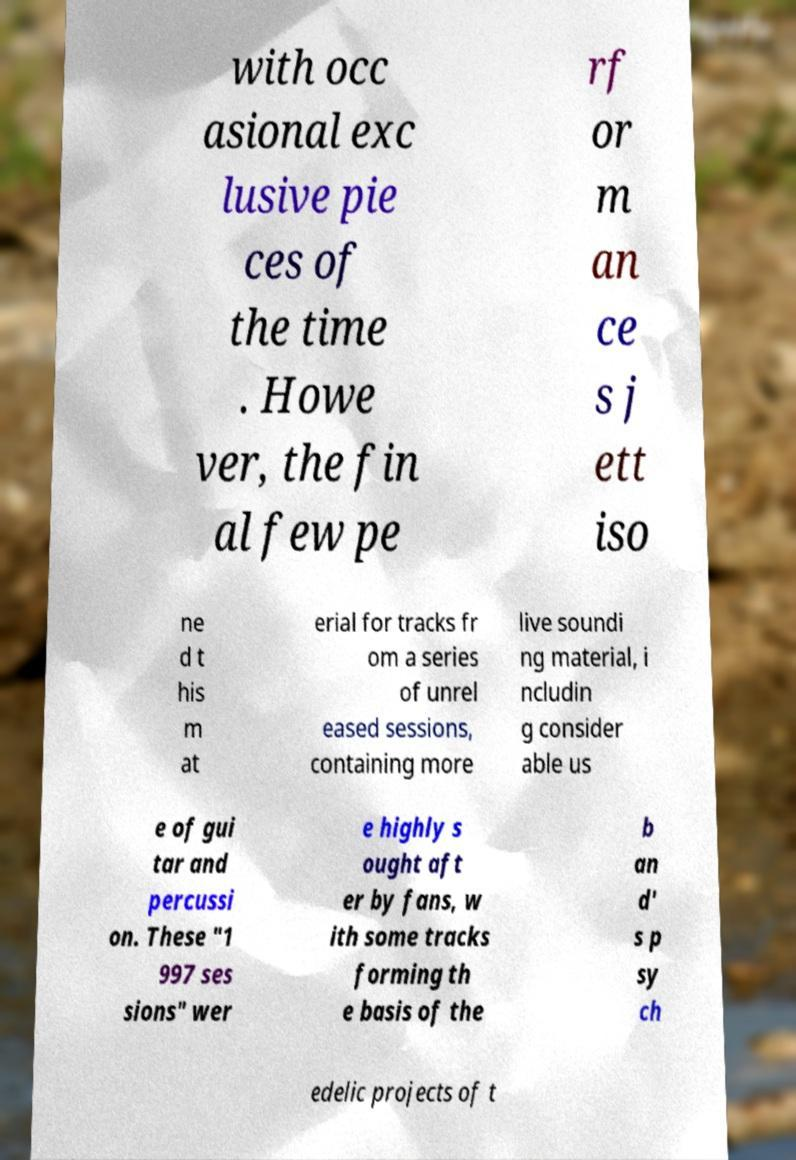Could you extract and type out the text from this image? with occ asional exc lusive pie ces of the time . Howe ver, the fin al few pe rf or m an ce s j ett iso ne d t his m at erial for tracks fr om a series of unrel eased sessions, containing more live soundi ng material, i ncludin g consider able us e of gui tar and percussi on. These "1 997 ses sions" wer e highly s ought aft er by fans, w ith some tracks forming th e basis of the b an d' s p sy ch edelic projects of t 